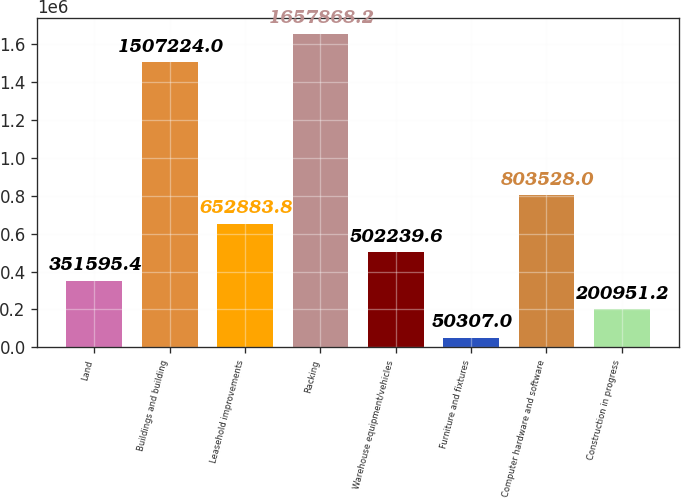<chart> <loc_0><loc_0><loc_500><loc_500><bar_chart><fcel>Land<fcel>Buildings and building<fcel>Leasehold improvements<fcel>Racking<fcel>Warehouse equipment/vehicles<fcel>Furniture and fixtures<fcel>Computer hardware and software<fcel>Construction in progress<nl><fcel>351595<fcel>1.50722e+06<fcel>652884<fcel>1.65787e+06<fcel>502240<fcel>50307<fcel>803528<fcel>200951<nl></chart> 